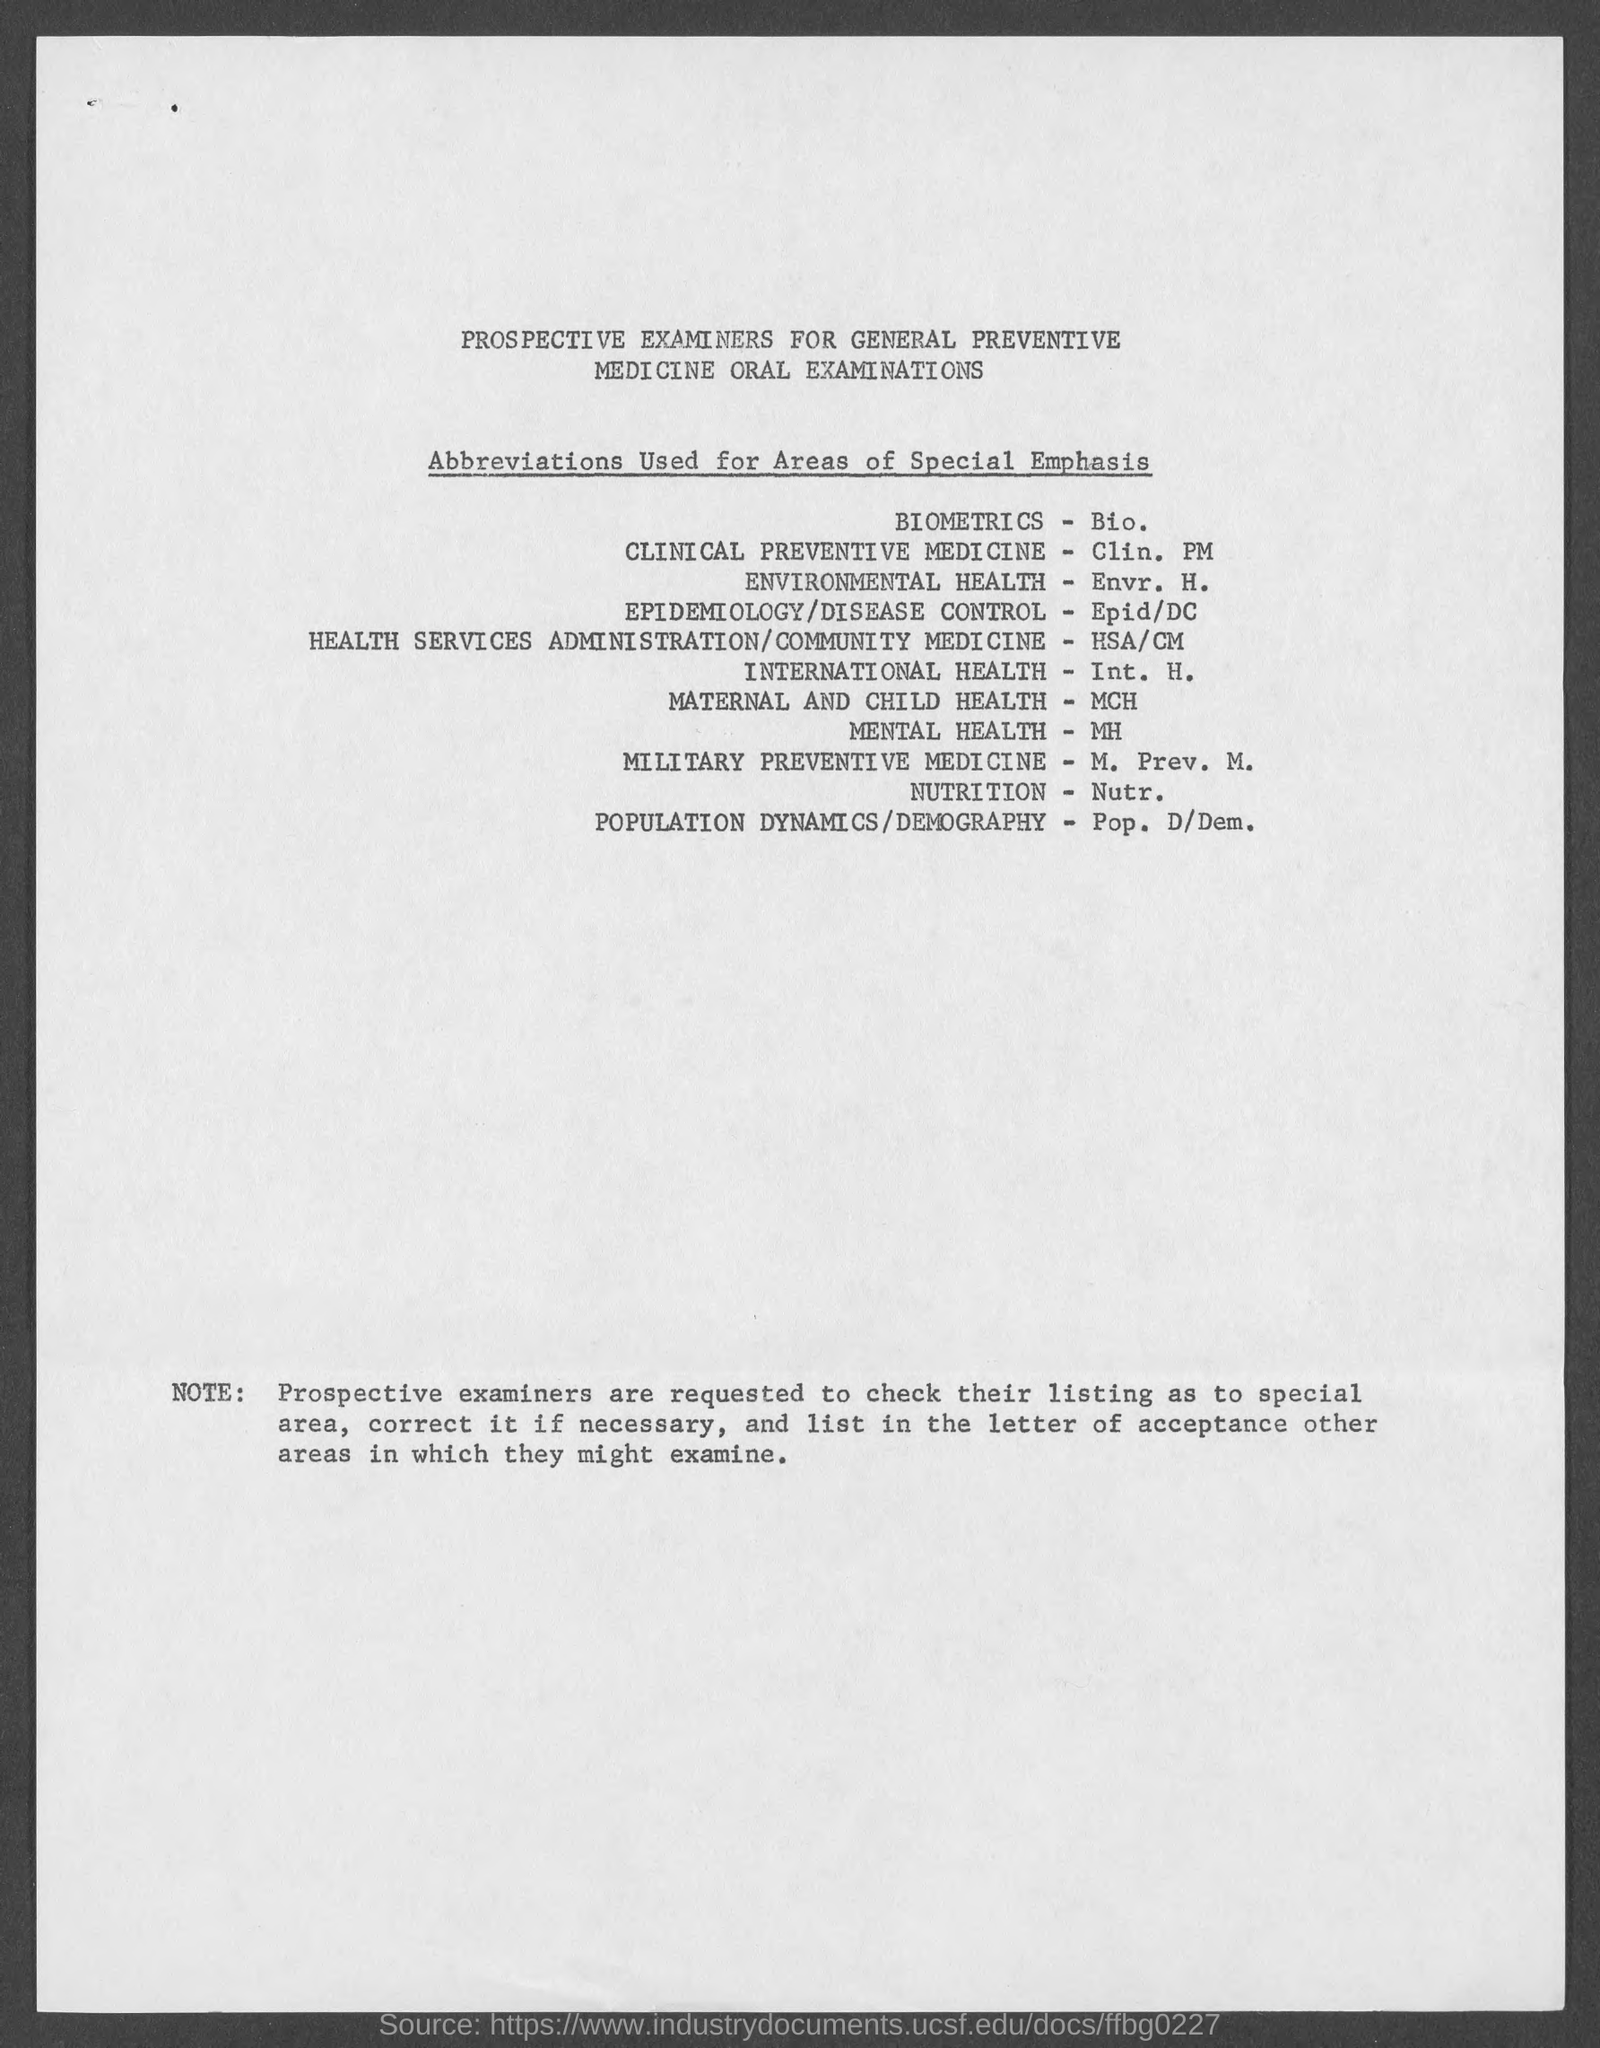Point out several critical features in this image. BIOMETRICS is a field of study that involves the use of biological data and information to develop technologies for identification and authentication purposes. Military Preventive Medicine is the abbreviation of M. Prev. Med. Pop. D/Dem refers to the field of Population Dynamics/Demography, which examines the changes in the size, composition, and distribution of a population over time. Clinical Preventive Medicine is defined as the practice of preventing or reducing the incidence of a disease or disorder through the use of clinical techniques and interventions, such as screening, counseling, and vaccination. 